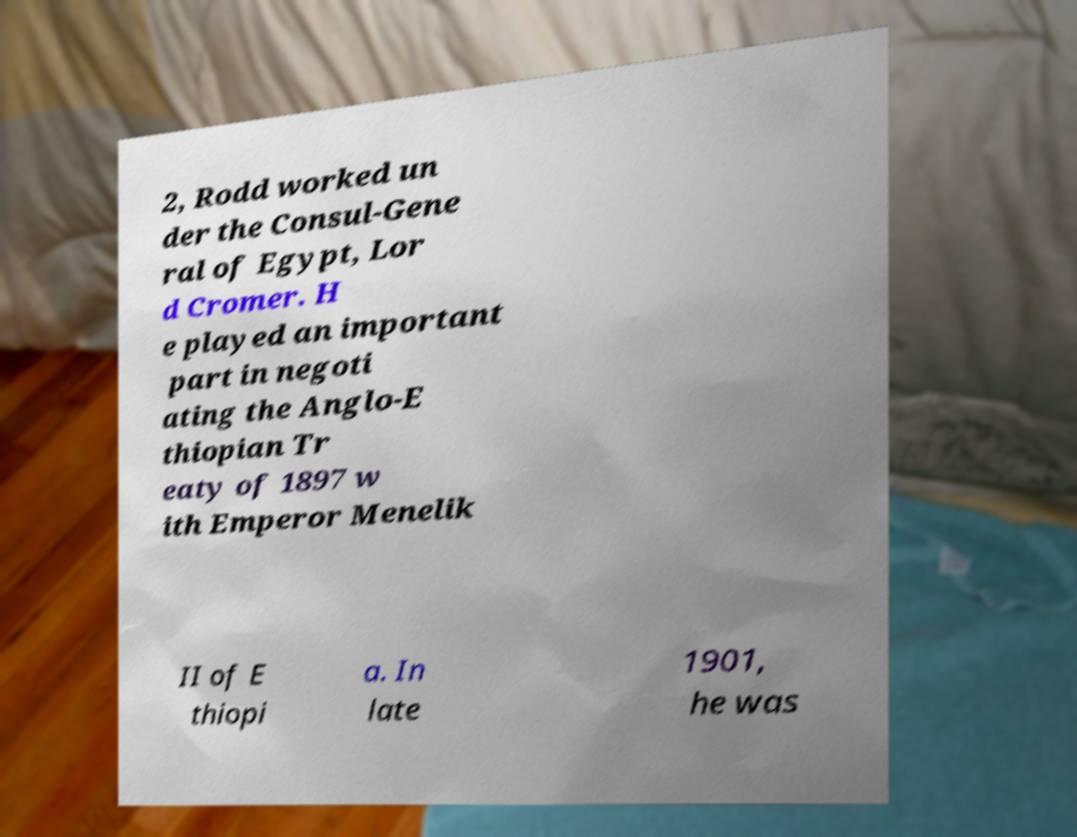What messages or text are displayed in this image? I need them in a readable, typed format. 2, Rodd worked un der the Consul-Gene ral of Egypt, Lor d Cromer. H e played an important part in negoti ating the Anglo-E thiopian Tr eaty of 1897 w ith Emperor Menelik II of E thiopi a. In late 1901, he was 